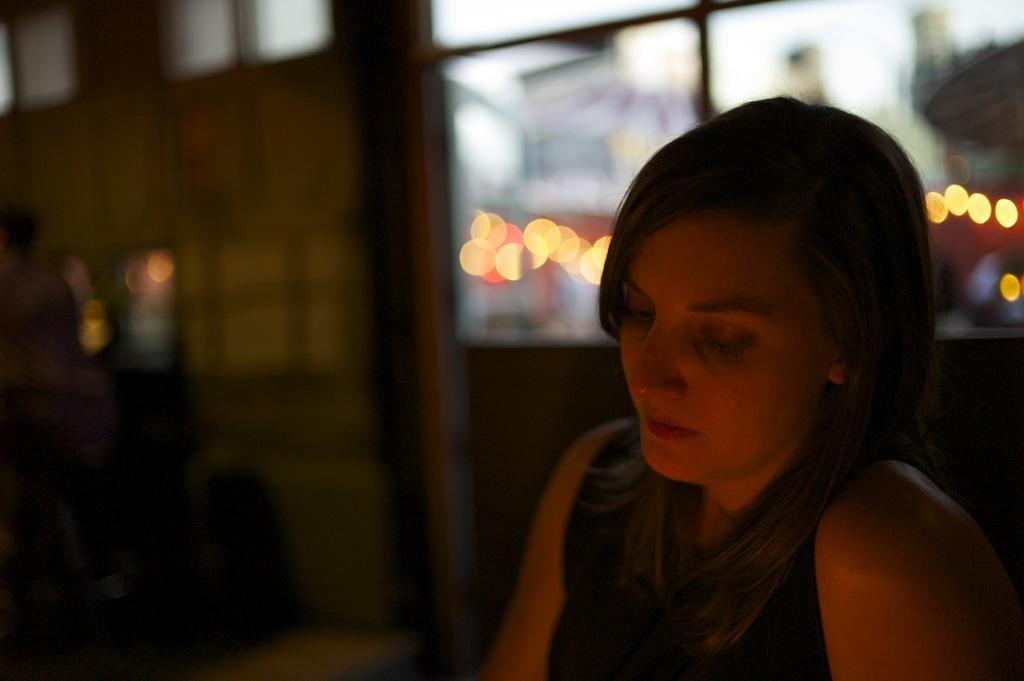In one or two sentences, can you explain what this image depicts? In this picture we can see a woman, in the background there is a wall, we can see a blurry background here. 